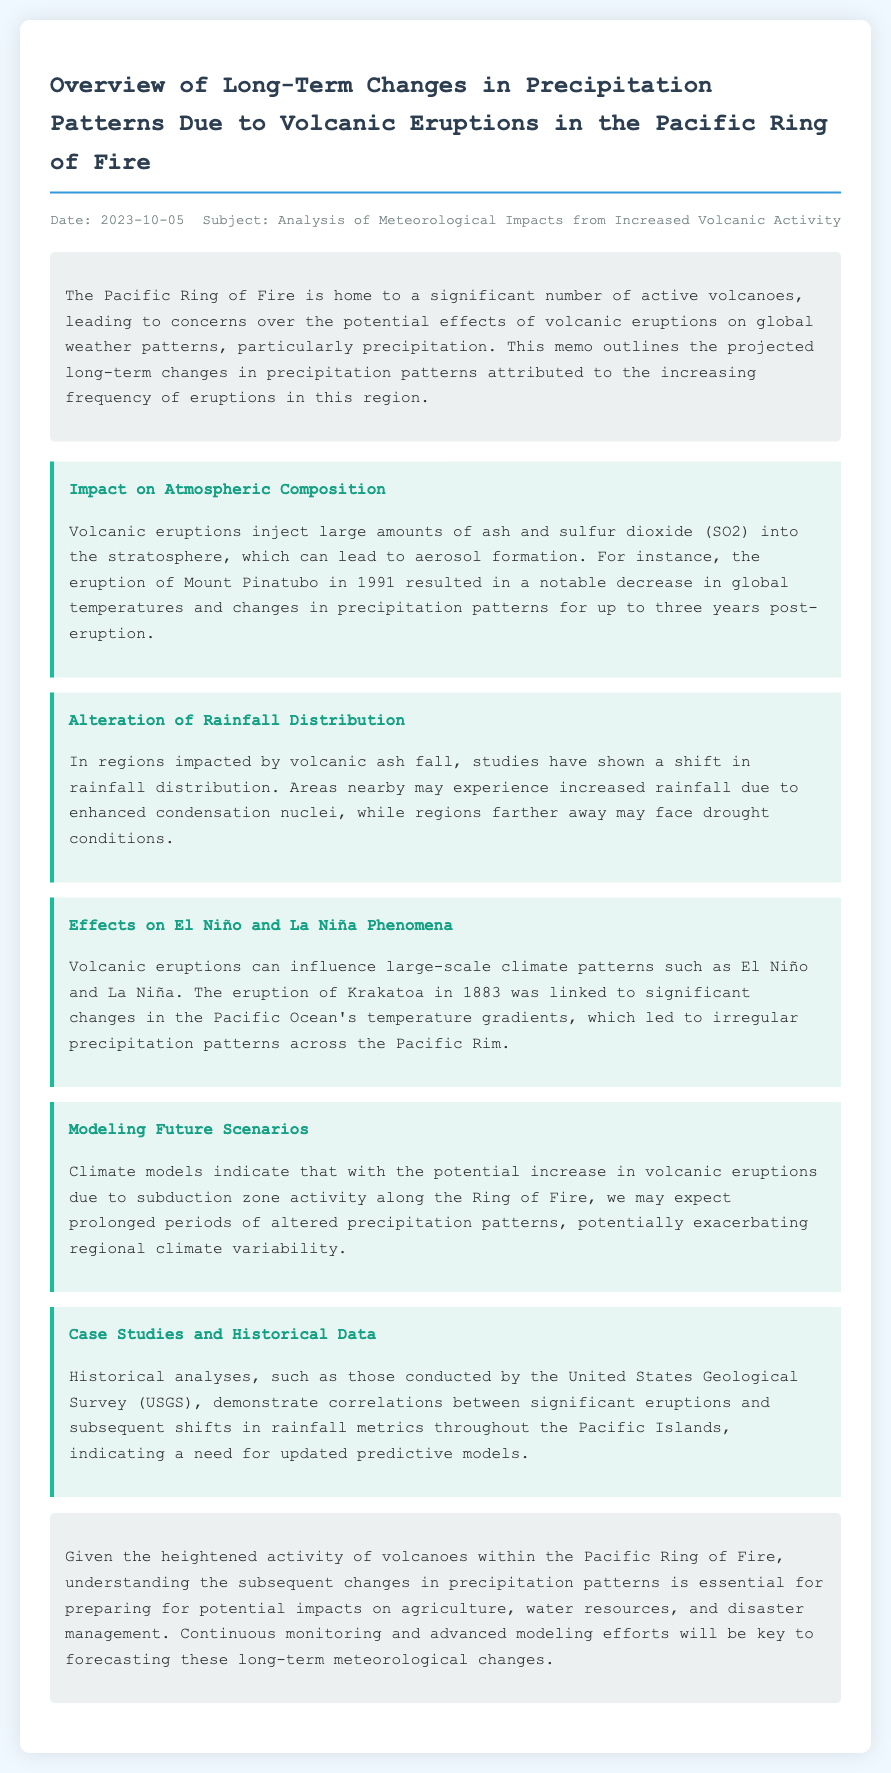What is the date of the memo? The date is mentioned in the header section of the memo.
Answer: 2023-10-05 What volcanic eruption is discussed as an example of atmospheric composition impact? The memo provides a specific example of a volcanic eruption that affected atmospheric composition.
Answer: Mount Pinatubo Which phenomenon's irregular precipitation patterns were linked to the eruption of Krakatoa? The memo describes how a specific eruption affected large-scale climate phenomena, which in turn affected precipitation patterns.
Answer: El Niño What is the title of this memo? The title is presented prominently at the beginning of the document.
Answer: Overview of Long-Term Changes in Precipitation Patterns Due to Volcanic Eruptions in the Pacific Ring of Fire What is one long-term impact of volcanic eruptions mentioned in the memo? The memo outlines various impacts and specifies one related to precipitation patterns.
Answer: Altered precipitation patterns Who conducted historical analyses related to volcanic eruptions and precipitation shifts? The memo attributes historical analysis efforts to a specific organization.
Answer: United States Geological Survey (USGS) What kind of data does the memo suggest is needed for updated predictive models? The memo highlights a form of data that is essential for modeling future precipitation changes.
Answer: Historical data What is the concern related to agriculture and water resources in the context of the memo? The conclusion highlights potential impacts on specific sectors due to precipitation changes attributed to volcanic eruptions.
Answer: Potential impacts on agriculture and water resources 